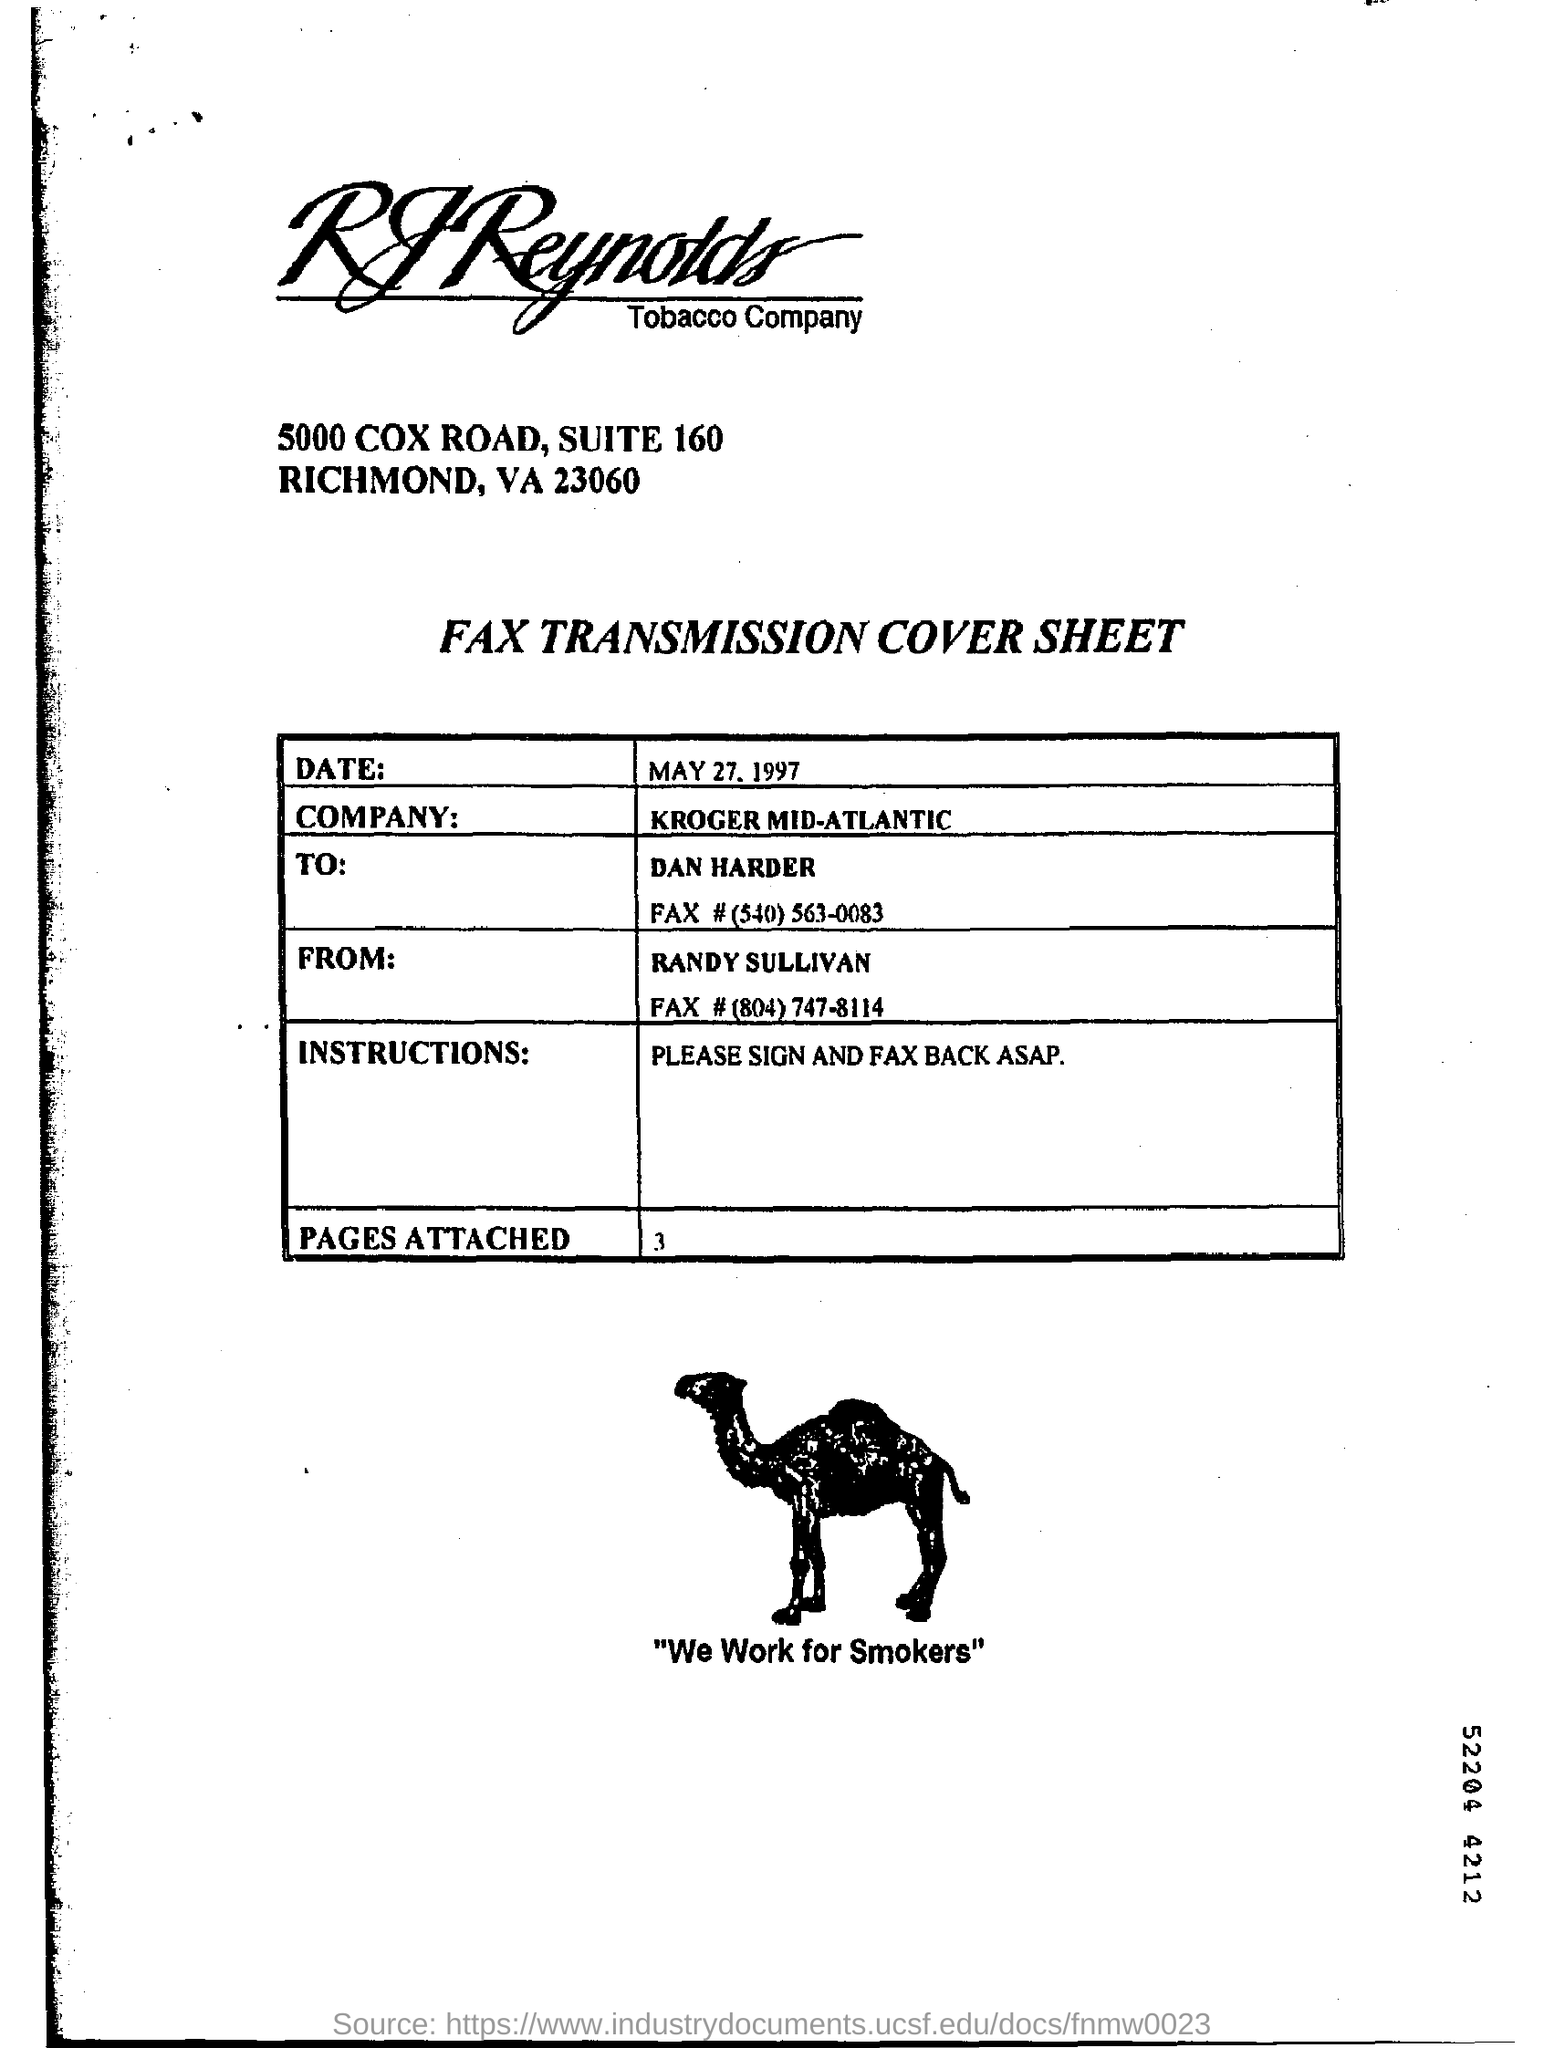Specify some key components in this picture. The date is May 27, 1997. Please sign and fax back the instructions as soon as possible. The name of the company is KROGER MID-ATLANTIC. 